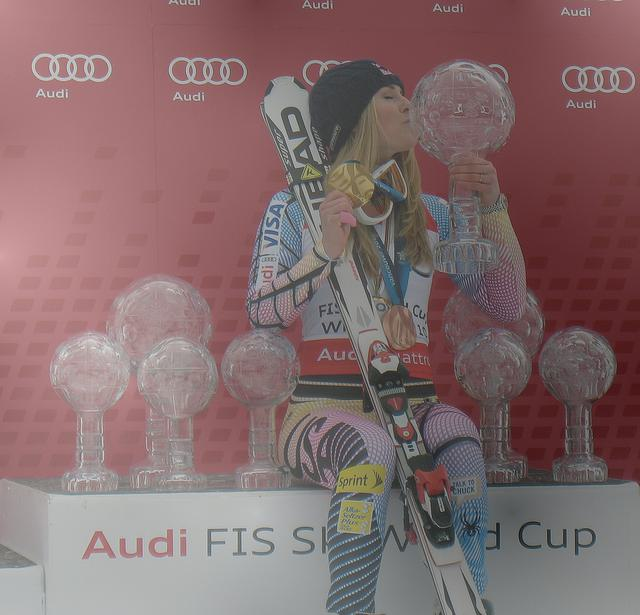What emotions does the athlete appear to be expressing? The athlete exudes a sense of joy and satisfaction. Her gesture of kissing the medal conveys a deep appreciation for her accomplishment, which is often associated with a hard-earned victory. 